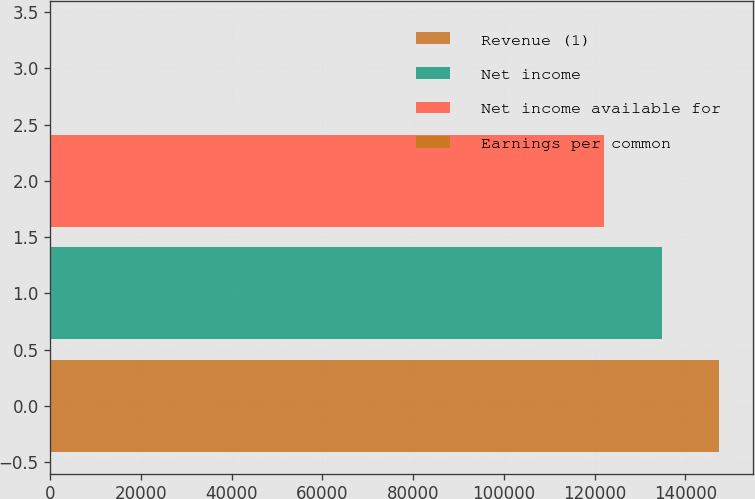Convert chart. <chart><loc_0><loc_0><loc_500><loc_500><bar_chart><fcel>Revenue (1)<fcel>Net income<fcel>Net income available for<fcel>Earnings per common<nl><fcel>147511<fcel>134772<fcel>122033<fcel>2.14<nl></chart> 